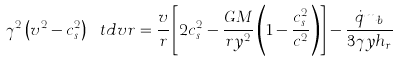Convert formula to latex. <formula><loc_0><loc_0><loc_500><loc_500>\gamma ^ { 2 } \left ( v ^ { 2 } - c _ { s } ^ { 2 } \right ) \ t d { v } { r } = \frac { v } { r } \left [ 2 c _ { s } ^ { 2 } - \frac { G M } { r y ^ { 2 } } \left ( 1 - \frac { c _ { s } ^ { 2 } } { c ^ { 2 } } \right ) \right ] - \frac { \dot { q } m _ { b } } { 3 \gamma y h _ { r } }</formula> 